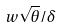<formula> <loc_0><loc_0><loc_500><loc_500>w \sqrt { \theta } / \delta</formula> 